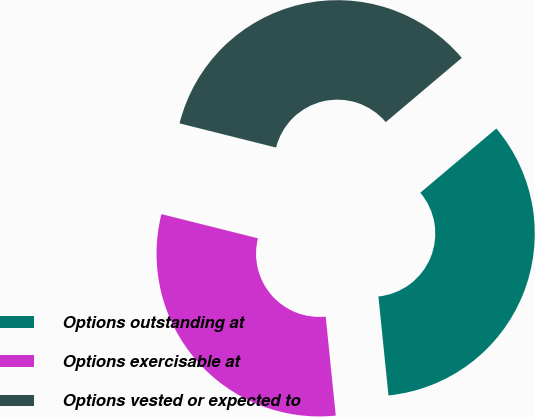Convert chart to OTSL. <chart><loc_0><loc_0><loc_500><loc_500><pie_chart><fcel>Options outstanding at<fcel>Options exercisable at<fcel>Options vested or expected to<nl><fcel>34.55%<fcel>30.52%<fcel>34.93%<nl></chart> 